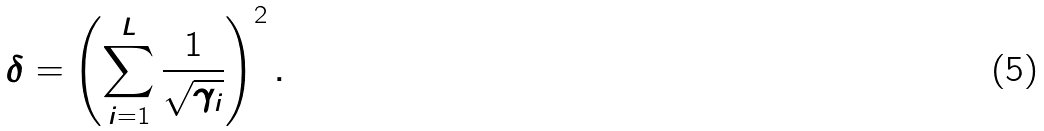Convert formula to latex. <formula><loc_0><loc_0><loc_500><loc_500>\delta = \left ( \sum _ { i = 1 } ^ { L } \frac { 1 } { \sqrt { \gamma _ { i } } } \right ) ^ { 2 } .</formula> 